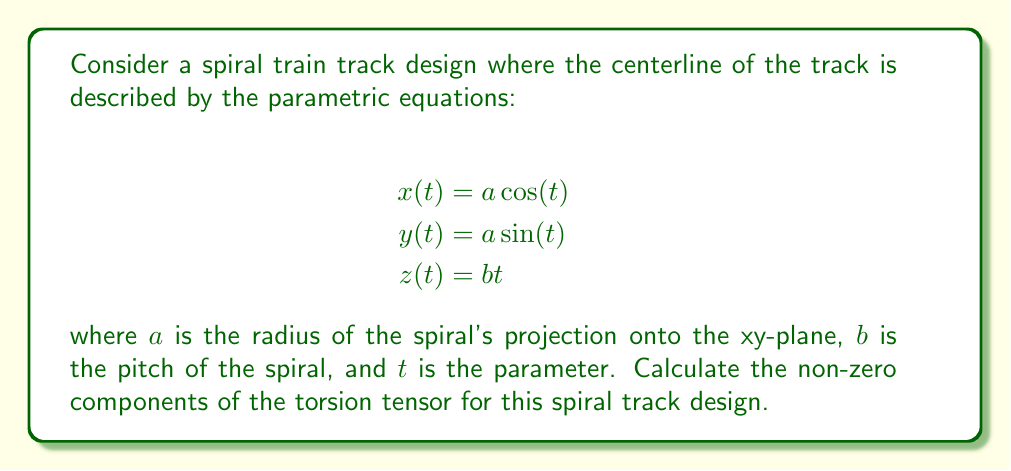Provide a solution to this math problem. To analyze the torsion tensor of the spiral train track, we'll follow these steps:

1) First, we need to calculate the tangent vector $\mathbf{T}$, normal vector $\mathbf{N}$, and binormal vector $\mathbf{B}$ of the curve.

2) The tangent vector is given by:
   $$\mathbf{T} = \frac{\mathbf{r}'(t)}{|\mathbf{r}'(t)|}$$
   where $\mathbf{r}(t) = (a\cos(t), a\sin(t), bt)$

3) Calculate $\mathbf{r}'(t)$:
   $$\mathbf{r}'(t) = (-a\sin(t), a\cos(t), b)$$

4) The magnitude of $\mathbf{r}'(t)$:
   $$|\mathbf{r}'(t)| = \sqrt{a^2\sin^2(t) + a^2\cos^2(t) + b^2} = \sqrt{a^2 + b^2}$$

5) Therefore, the tangent vector is:
   $$\mathbf{T} = \frac{1}{\sqrt{a^2 + b^2}}(-a\sin(t), a\cos(t), b)$$

6) The curvature $\kappa$ is given by:
   $$\kappa = \frac{|\mathbf{r}'(t) \times \mathbf{r}''(t)|}{|\mathbf{r}'(t)|^3}$$

7) Calculate $\mathbf{r}''(t)$:
   $$\mathbf{r}''(t) = (-a\cos(t), -a\sin(t), 0)$$

8) Calculate $\mathbf{r}'(t) \times \mathbf{r}''(t)$:
   $$\mathbf{r}'(t) \times \mathbf{r}''(t) = (ab\sin(t), -ab\cos(t), a^2)$$

9) The magnitude of this cross product:
   $$|\mathbf{r}'(t) \times \mathbf{r}''(t)| = \sqrt{a^2b^2\sin^2(t) + a^2b^2\cos^2(t) + a^4} = a\sqrt{a^2 + b^2}$$

10) Therefore, the curvature is:
    $$\kappa = \frac{a}{(a^2 + b^2)}$$

11) The normal vector is:
    $$\mathbf{N} = \frac{\mathbf{T}'}{\kappa|\mathbf{r}'(t)|} = (-\cos(t), -\sin(t), 0)$$

12) The binormal vector is:
    $$\mathbf{B} = \mathbf{T} \times \mathbf{N} = \frac{1}{\sqrt{a^2 + b^2}}(b\sin(t), -b\cos(t), a)$$

13) The torsion $\tau$ is given by:
    $$\tau = -\mathbf{B}' \cdot \mathbf{N}$$

14) Calculate $\mathbf{B}'$:
    $$\mathbf{B}' = \frac{1}{\sqrt{a^2 + b^2}}(b\cos(t), b\sin(t), 0)$$

15) Therefore, the torsion is:
    $$\tau = -\frac{1}{\sqrt{a^2 + b^2}}(b\cos(t), b\sin(t), 0) \cdot (-\cos(t), -\sin(t), 0) = \frac{b}{a^2 + b^2}$$

16) The torsion tensor $T_{ijk}$ in terms of the Frenet frame is given by:
    $$T_{ijk} = \tau(\delta_{i2}\delta_{j3} - \delta_{i3}\delta_{j2})$$

17) The non-zero components of the torsion tensor are:
    $$T_{123} = -T_{132} = \tau = \frac{b}{a^2 + b^2}$$
Answer: $T_{123} = -T_{132} = \frac{b}{a^2 + b^2}$ 